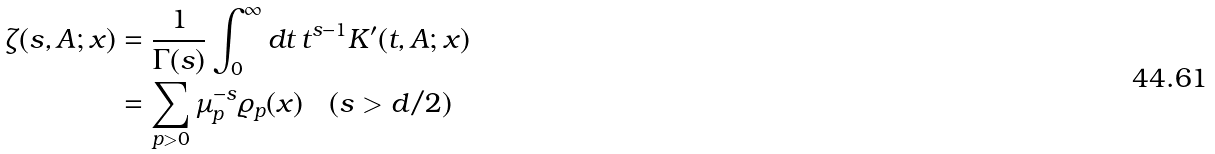<formula> <loc_0><loc_0><loc_500><loc_500>\zeta ( s , A ; x ) & = \frac { 1 } { \Gamma ( s ) } \int _ { 0 } ^ { \infty } d t \, t ^ { s - 1 } K ^ { \prime } ( t , A ; x ) \\ & = \sum _ { p > 0 } \mu _ { p } ^ { - s } \varrho _ { p } ( x ) \quad ( s > d / 2 )</formula> 